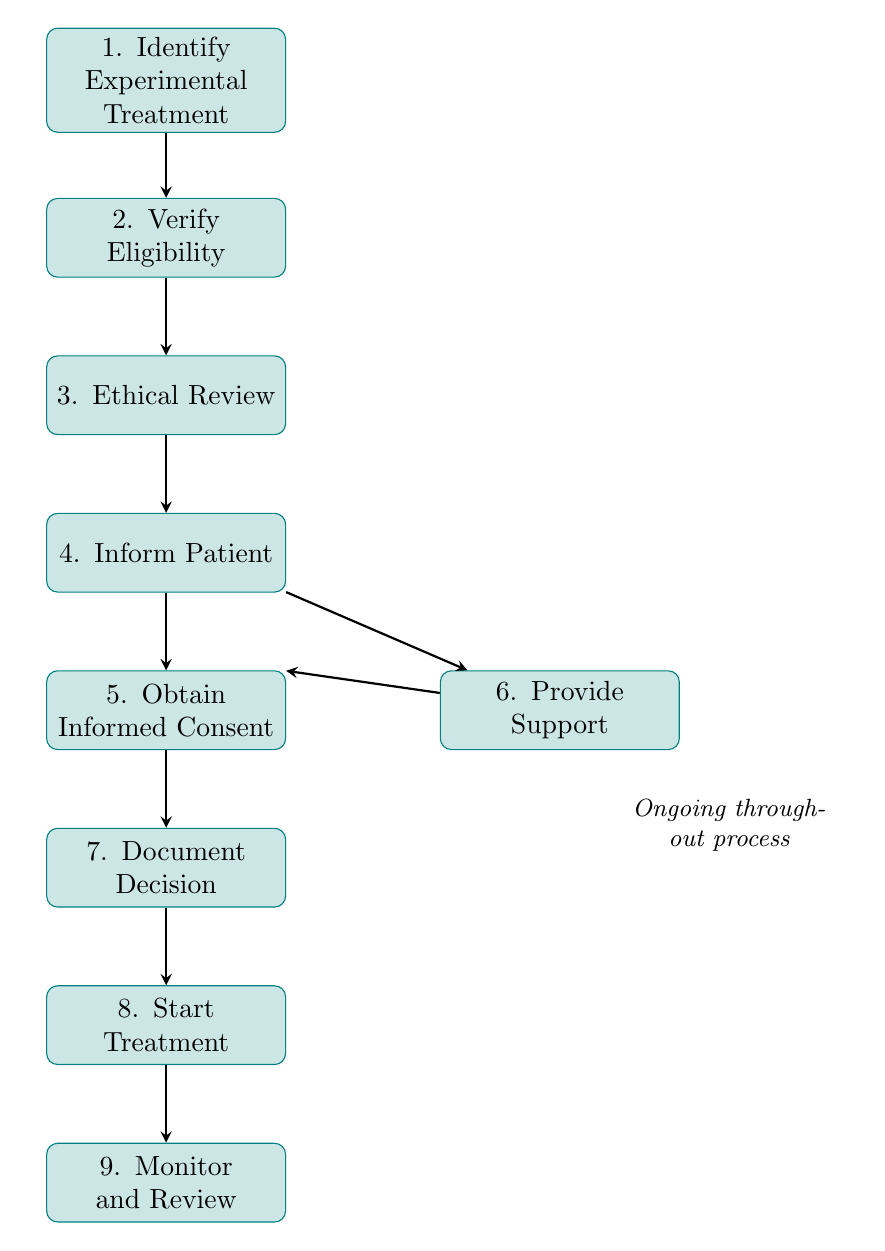What is the first step in the pathway? The first step in the pathway is clearly labeled as "1. Identify Experimental Treatment" in the diagram.
Answer: Identify Experimental Treatment How many nodes are there in total? The diagram contains nine distinct nodes that represent various steps in the process of informing patients about experimental treatments.
Answer: Nine What is the last step in the flow? The last step, as indicated at the bottom of the diagram, is "9. Monitor and Review."
Answer: Monitor and Review Which step involves ethical review? The step that involves the ethical review is labeled "3. Ethical Review" in the flowchart.
Answer: Ethical Review In which step is patient consent collected? Patient consent is collected in the step labeled "5. Obtain Informed Consent," which is explicitly outlined in the diagram.
Answer: Obtain Informed Consent Which process occurs simultaneously with informed consent? The process that occurs simultaneously is "6. Provide Support," which is connected to the informed consent step but positioned to the right of it.
Answer: Provide Support What action follows after documenting the decision? After the decision is documented in "7. Document Decision," the next action is "8. Start Treatment," as indicated by the directed arrow in the flowchart.
Answer: Start Treatment How are the steps related to each other? The steps are sequentially connected through arrows, indicating a flow from one step to the next, with some having simultaneous processes (like support during consent).
Answer: Sequentially connected What is the main focus of "Inform Patient"? The main focus of "Inform Patient" is to communicate details about the experimental treatment, including risks, benefits, and alternatives, as described in the node.
Answer: Communicate details 